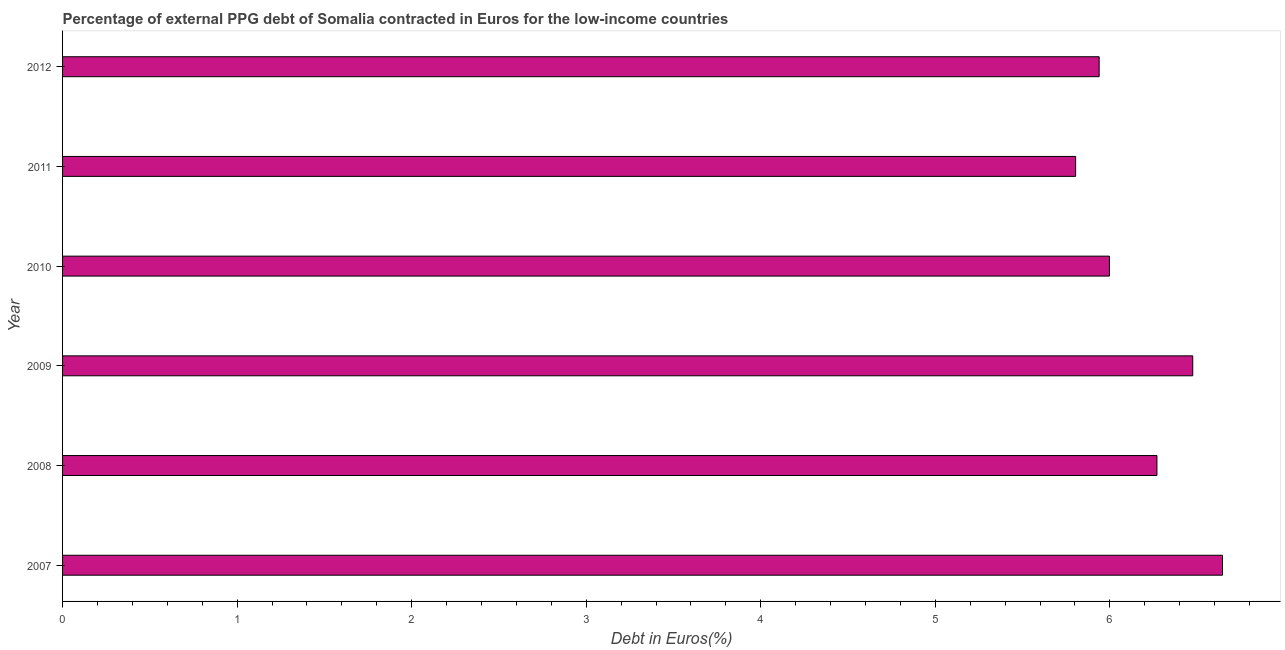What is the title of the graph?
Your response must be concise. Percentage of external PPG debt of Somalia contracted in Euros for the low-income countries. What is the label or title of the X-axis?
Make the answer very short. Debt in Euros(%). What is the currency composition of ppg debt in 2011?
Your response must be concise. 5.8. Across all years, what is the maximum currency composition of ppg debt?
Offer a very short reply. 6.65. Across all years, what is the minimum currency composition of ppg debt?
Give a very brief answer. 5.8. In which year was the currency composition of ppg debt maximum?
Ensure brevity in your answer.  2007. What is the sum of the currency composition of ppg debt?
Provide a short and direct response. 37.13. What is the difference between the currency composition of ppg debt in 2010 and 2011?
Offer a terse response. 0.19. What is the average currency composition of ppg debt per year?
Give a very brief answer. 6.19. What is the median currency composition of ppg debt?
Provide a succinct answer. 6.13. Do a majority of the years between 2007 and 2012 (inclusive) have currency composition of ppg debt greater than 6.6 %?
Give a very brief answer. No. Is the difference between the currency composition of ppg debt in 2008 and 2011 greater than the difference between any two years?
Your response must be concise. No. What is the difference between the highest and the second highest currency composition of ppg debt?
Provide a short and direct response. 0.17. Is the sum of the currency composition of ppg debt in 2007 and 2008 greater than the maximum currency composition of ppg debt across all years?
Your answer should be compact. Yes. What is the difference between the highest and the lowest currency composition of ppg debt?
Ensure brevity in your answer.  0.84. In how many years, is the currency composition of ppg debt greater than the average currency composition of ppg debt taken over all years?
Your answer should be very brief. 3. Are all the bars in the graph horizontal?
Provide a short and direct response. Yes. How many years are there in the graph?
Make the answer very short. 6. What is the Debt in Euros(%) in 2007?
Offer a terse response. 6.65. What is the Debt in Euros(%) in 2008?
Your answer should be compact. 6.27. What is the Debt in Euros(%) in 2009?
Keep it short and to the point. 6.48. What is the Debt in Euros(%) in 2010?
Make the answer very short. 6. What is the Debt in Euros(%) of 2011?
Your answer should be very brief. 5.8. What is the Debt in Euros(%) of 2012?
Offer a terse response. 5.94. What is the difference between the Debt in Euros(%) in 2007 and 2008?
Offer a very short reply. 0.38. What is the difference between the Debt in Euros(%) in 2007 and 2009?
Give a very brief answer. 0.17. What is the difference between the Debt in Euros(%) in 2007 and 2010?
Provide a succinct answer. 0.65. What is the difference between the Debt in Euros(%) in 2007 and 2011?
Offer a terse response. 0.84. What is the difference between the Debt in Euros(%) in 2007 and 2012?
Your response must be concise. 0.71. What is the difference between the Debt in Euros(%) in 2008 and 2009?
Keep it short and to the point. -0.21. What is the difference between the Debt in Euros(%) in 2008 and 2010?
Your response must be concise. 0.27. What is the difference between the Debt in Euros(%) in 2008 and 2011?
Provide a short and direct response. 0.47. What is the difference between the Debt in Euros(%) in 2008 and 2012?
Provide a short and direct response. 0.33. What is the difference between the Debt in Euros(%) in 2009 and 2010?
Offer a very short reply. 0.48. What is the difference between the Debt in Euros(%) in 2009 and 2011?
Keep it short and to the point. 0.67. What is the difference between the Debt in Euros(%) in 2009 and 2012?
Ensure brevity in your answer.  0.54. What is the difference between the Debt in Euros(%) in 2010 and 2011?
Offer a terse response. 0.19. What is the difference between the Debt in Euros(%) in 2010 and 2012?
Ensure brevity in your answer.  0.06. What is the difference between the Debt in Euros(%) in 2011 and 2012?
Provide a short and direct response. -0.13. What is the ratio of the Debt in Euros(%) in 2007 to that in 2008?
Your answer should be compact. 1.06. What is the ratio of the Debt in Euros(%) in 2007 to that in 2010?
Give a very brief answer. 1.11. What is the ratio of the Debt in Euros(%) in 2007 to that in 2011?
Give a very brief answer. 1.15. What is the ratio of the Debt in Euros(%) in 2007 to that in 2012?
Ensure brevity in your answer.  1.12. What is the ratio of the Debt in Euros(%) in 2008 to that in 2009?
Provide a short and direct response. 0.97. What is the ratio of the Debt in Euros(%) in 2008 to that in 2010?
Make the answer very short. 1.04. What is the ratio of the Debt in Euros(%) in 2008 to that in 2012?
Make the answer very short. 1.06. What is the ratio of the Debt in Euros(%) in 2009 to that in 2011?
Your answer should be compact. 1.12. What is the ratio of the Debt in Euros(%) in 2009 to that in 2012?
Your answer should be very brief. 1.09. What is the ratio of the Debt in Euros(%) in 2010 to that in 2011?
Keep it short and to the point. 1.03. What is the ratio of the Debt in Euros(%) in 2011 to that in 2012?
Your answer should be very brief. 0.98. 